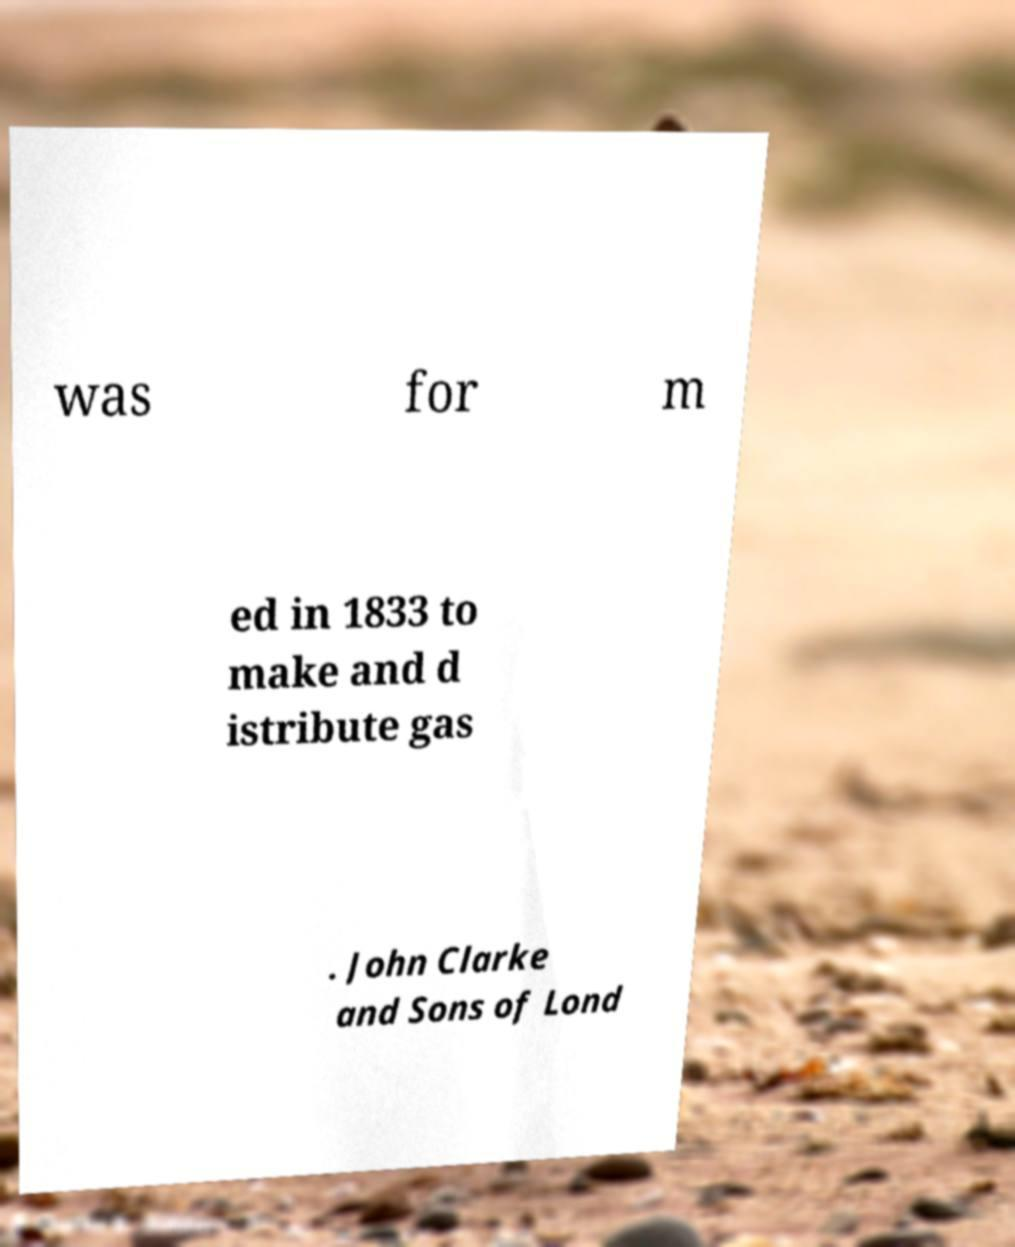Could you extract and type out the text from this image? was for m ed in 1833 to make and d istribute gas . John Clarke and Sons of Lond 